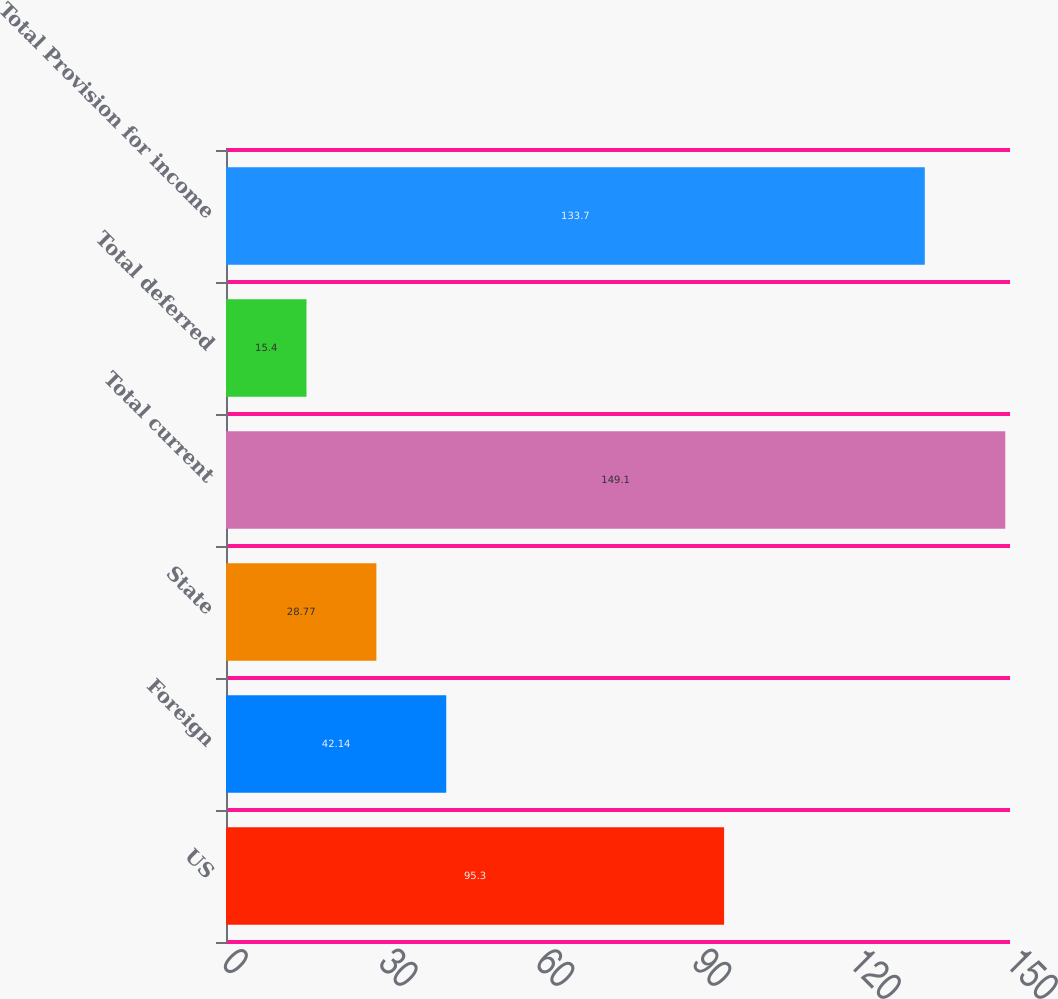<chart> <loc_0><loc_0><loc_500><loc_500><bar_chart><fcel>US<fcel>Foreign<fcel>State<fcel>Total current<fcel>Total deferred<fcel>Total Provision for income<nl><fcel>95.3<fcel>42.14<fcel>28.77<fcel>149.1<fcel>15.4<fcel>133.7<nl></chart> 